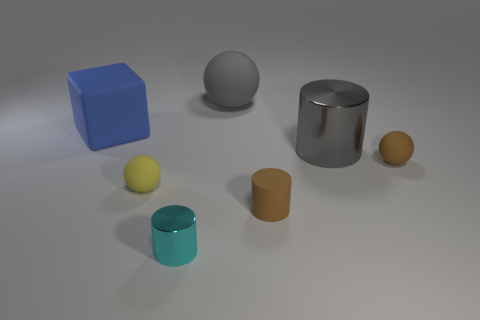Subtract all balls. How many objects are left? 4 Subtract all tiny matte spheres. How many spheres are left? 1 Subtract 1 blocks. How many blocks are left? 0 Add 4 tiny metallic things. How many tiny metallic things are left? 5 Add 1 green metal objects. How many green metal objects exist? 1 Add 2 gray rubber objects. How many objects exist? 9 Subtract all yellow spheres. How many spheres are left? 2 Subtract 0 blue balls. How many objects are left? 7 Subtract all gray balls. Subtract all brown cubes. How many balls are left? 2 Subtract all green cylinders. How many brown spheres are left? 1 